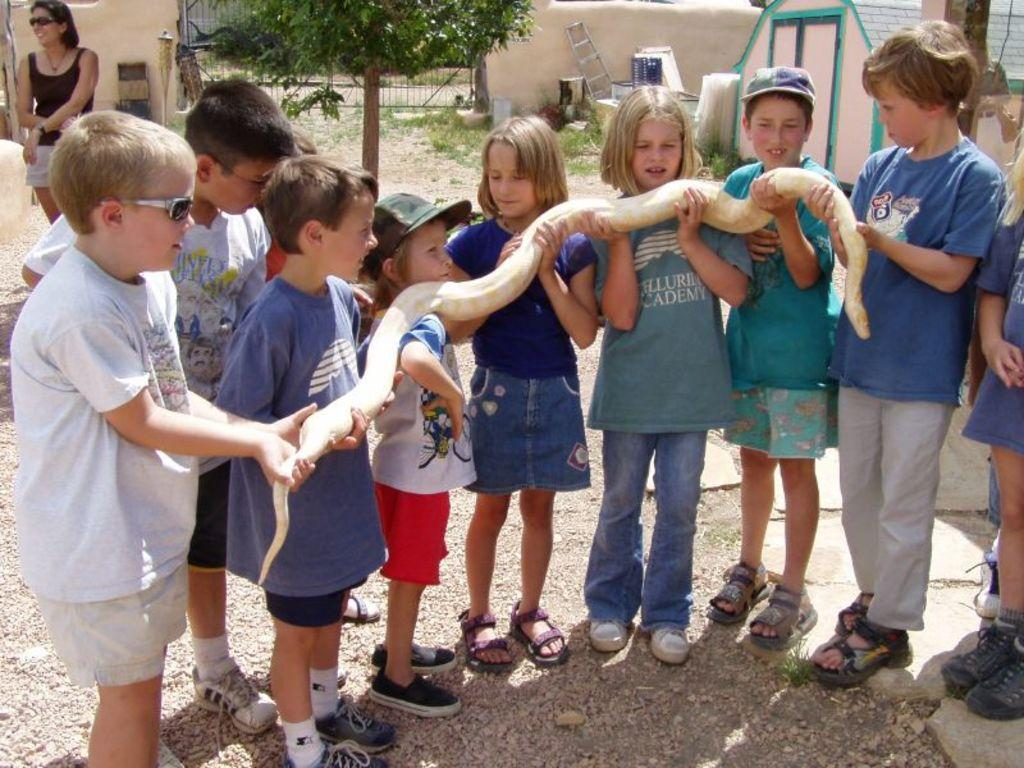What are the kids doing in the center of the image? The kids are holding a snake in the center of the image. What can be seen in the background of the image? There is a person, a gate, a wall, a ladder, a building, and grass in the background of the image. What decision did the tree make in the image? There is no tree present in the image, so no decision can be attributed to a tree. 